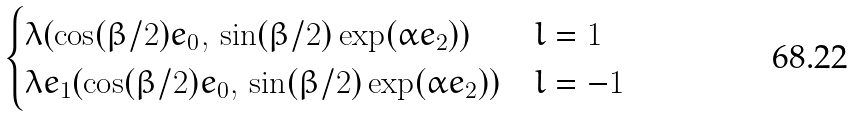<formula> <loc_0><loc_0><loc_500><loc_500>\begin{cases} \lambda ( \cos ( \beta / 2 ) e _ { 0 } , \, \sin ( \beta / 2 ) \exp ( \alpha e _ { 2 } ) ) & l = 1 \\ \lambda e _ { 1 } ( \cos ( \beta / 2 ) e _ { 0 } , \, \sin ( \beta / 2 ) \exp ( \alpha e _ { 2 } ) ) & l = - 1 \end{cases}</formula> 